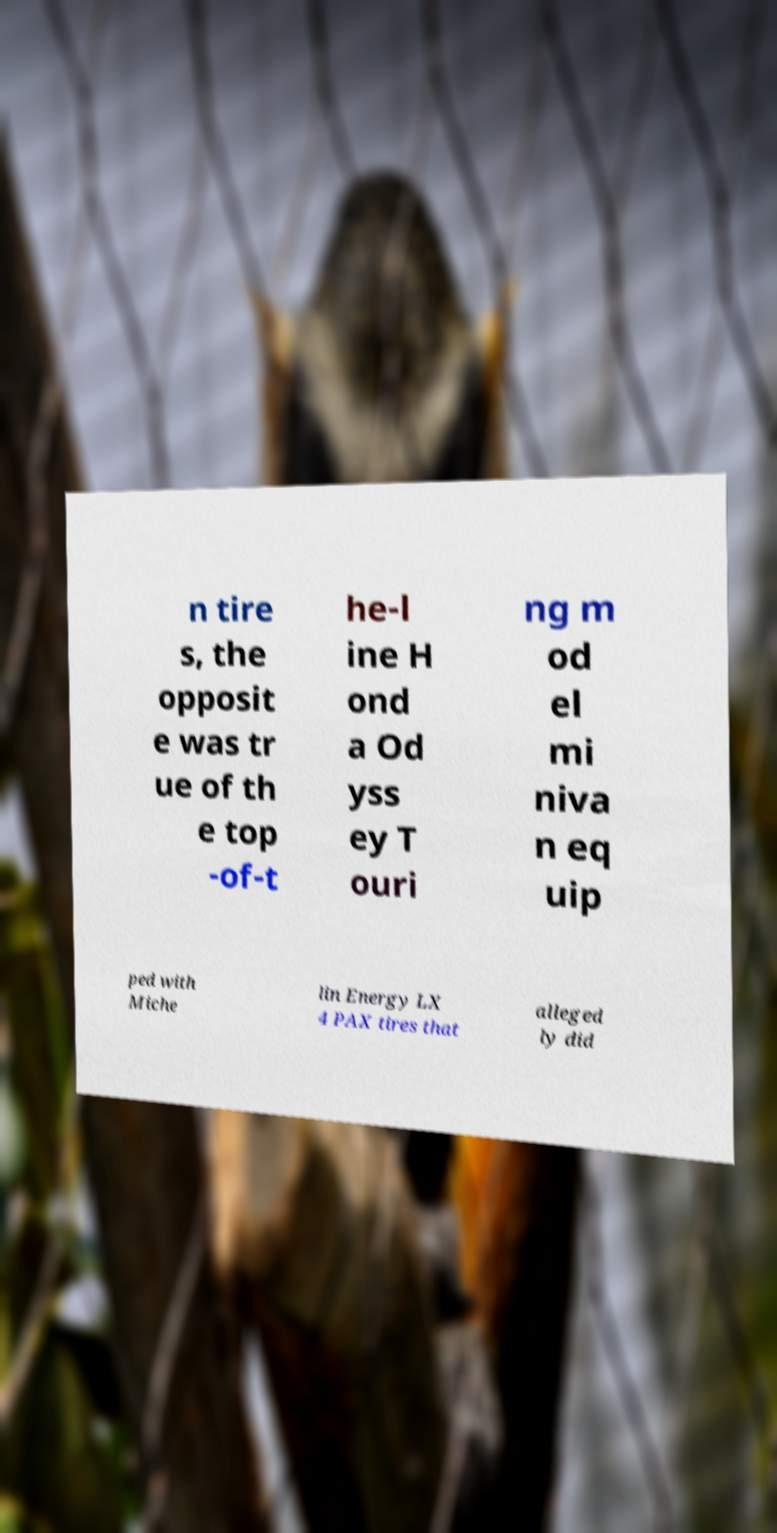Can you accurately transcribe the text from the provided image for me? n tire s, the opposit e was tr ue of th e top -of-t he-l ine H ond a Od yss ey T ouri ng m od el mi niva n eq uip ped with Miche lin Energy LX 4 PAX tires that alleged ly did 